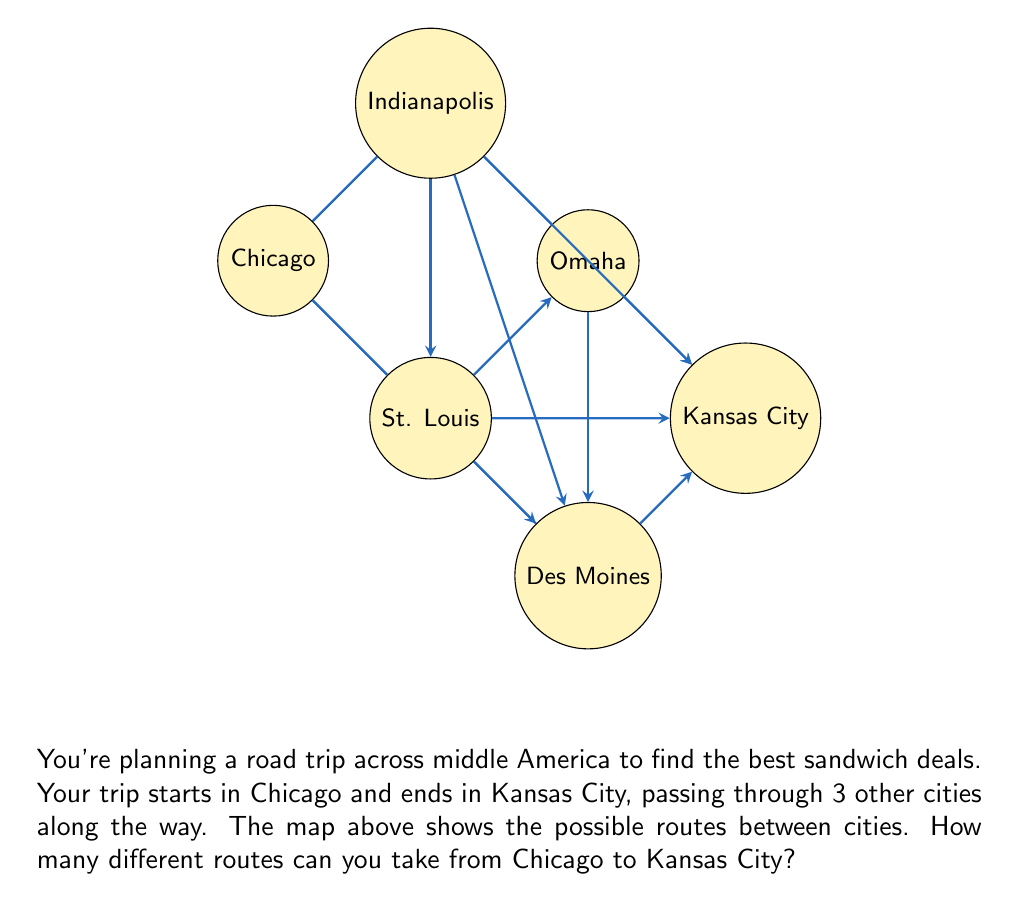What is the answer to this math problem? Let's approach this step-by-step using the principles of combinatorics:

1) We need to choose 3 cities to visit between Chicago and Kansas City. 

2) From Chicago, we have 2 choices: St. Louis or Indianapolis.

3) If we choose St. Louis:
   - We can go directly to Kansas City (1 route)
   - We can go to Des Moines, then Kansas City (1 route)
   - We can go to Omaha, then Kansas City (1 route)
   Total routes through St. Louis: 3

4) If we choose Indianapolis:
   - We can go directly to Kansas City (1 route)
   - We can go to St. Louis, then Kansas City (1 route)
   - We can go to Omaha, then Kansas City (1 route)
   - We can go to Des Moines, then Kansas City (1 route)
   Total routes through Indianapolis: 4

5) To find the total number of routes, we sum the routes through St. Louis and Indianapolis:

   $$ \text{Total Routes} = \text{Routes through St. Louis} + \text{Routes through Indianapolis} $$
   $$ \text{Total Routes} = 3 + 4 = 7 $$

Therefore, there are 7 different routes you can take from Chicago to Kansas City.
Answer: 7 routes 